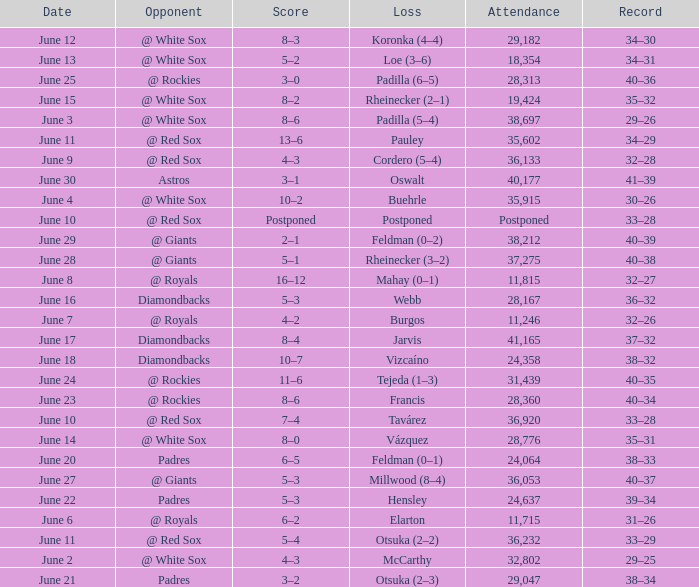When did tavárez lose? June 10. 